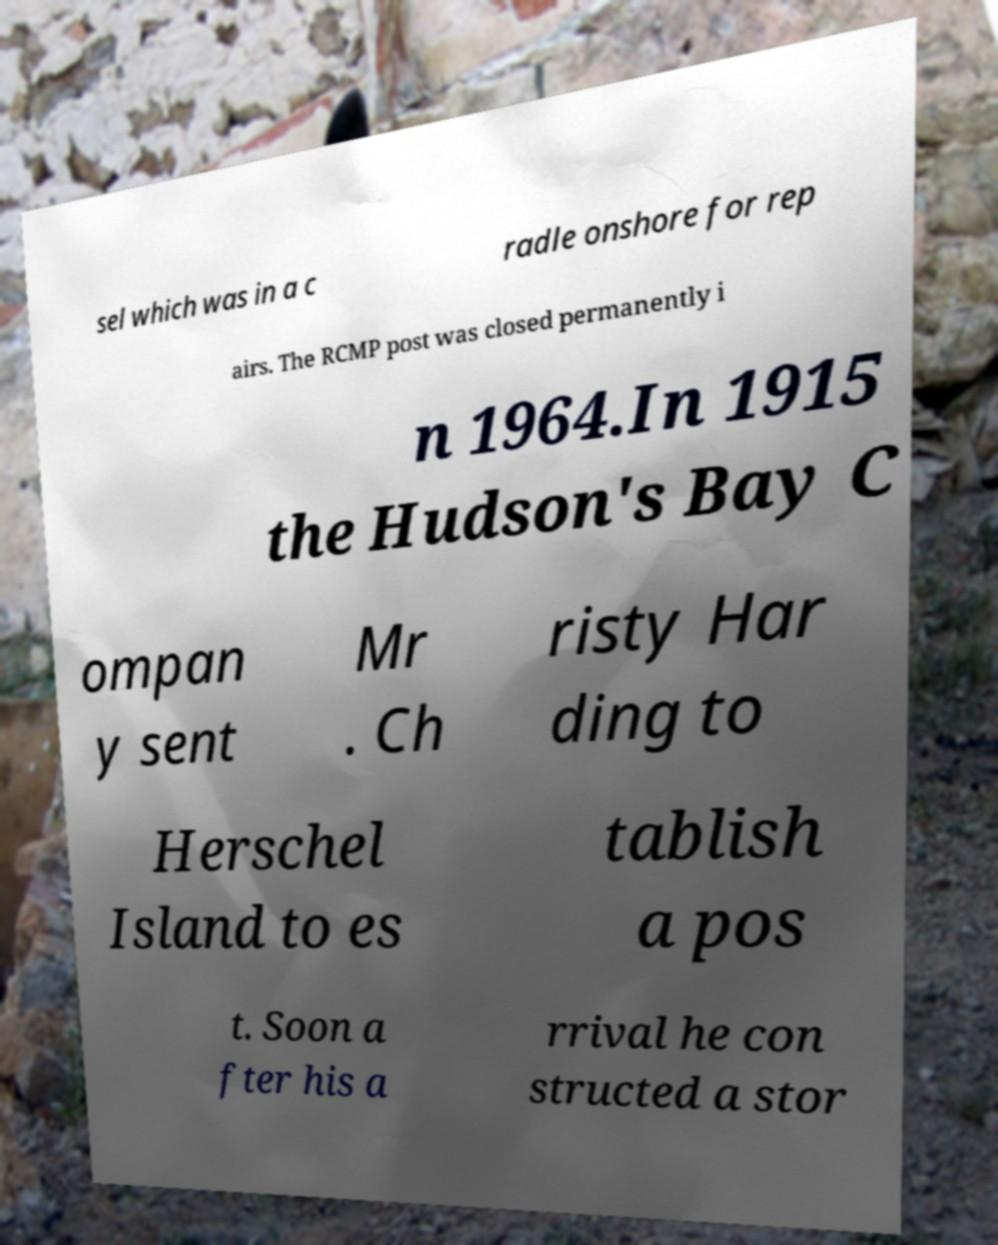Please identify and transcribe the text found in this image. sel which was in a c radle onshore for rep airs. The RCMP post was closed permanently i n 1964.In 1915 the Hudson's Bay C ompan y sent Mr . Ch risty Har ding to Herschel Island to es tablish a pos t. Soon a fter his a rrival he con structed a stor 